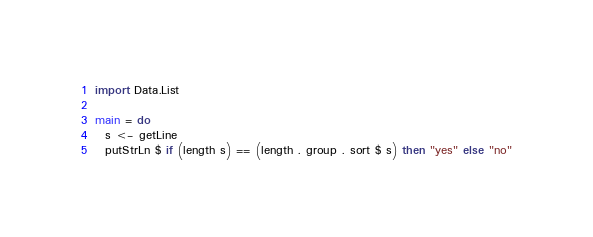<code> <loc_0><loc_0><loc_500><loc_500><_Haskell_>import Data.List

main = do
  s <- getLine
  putStrLn $ if (length s) == (length . group . sort $ s) then "yes" else "no"
</code> 